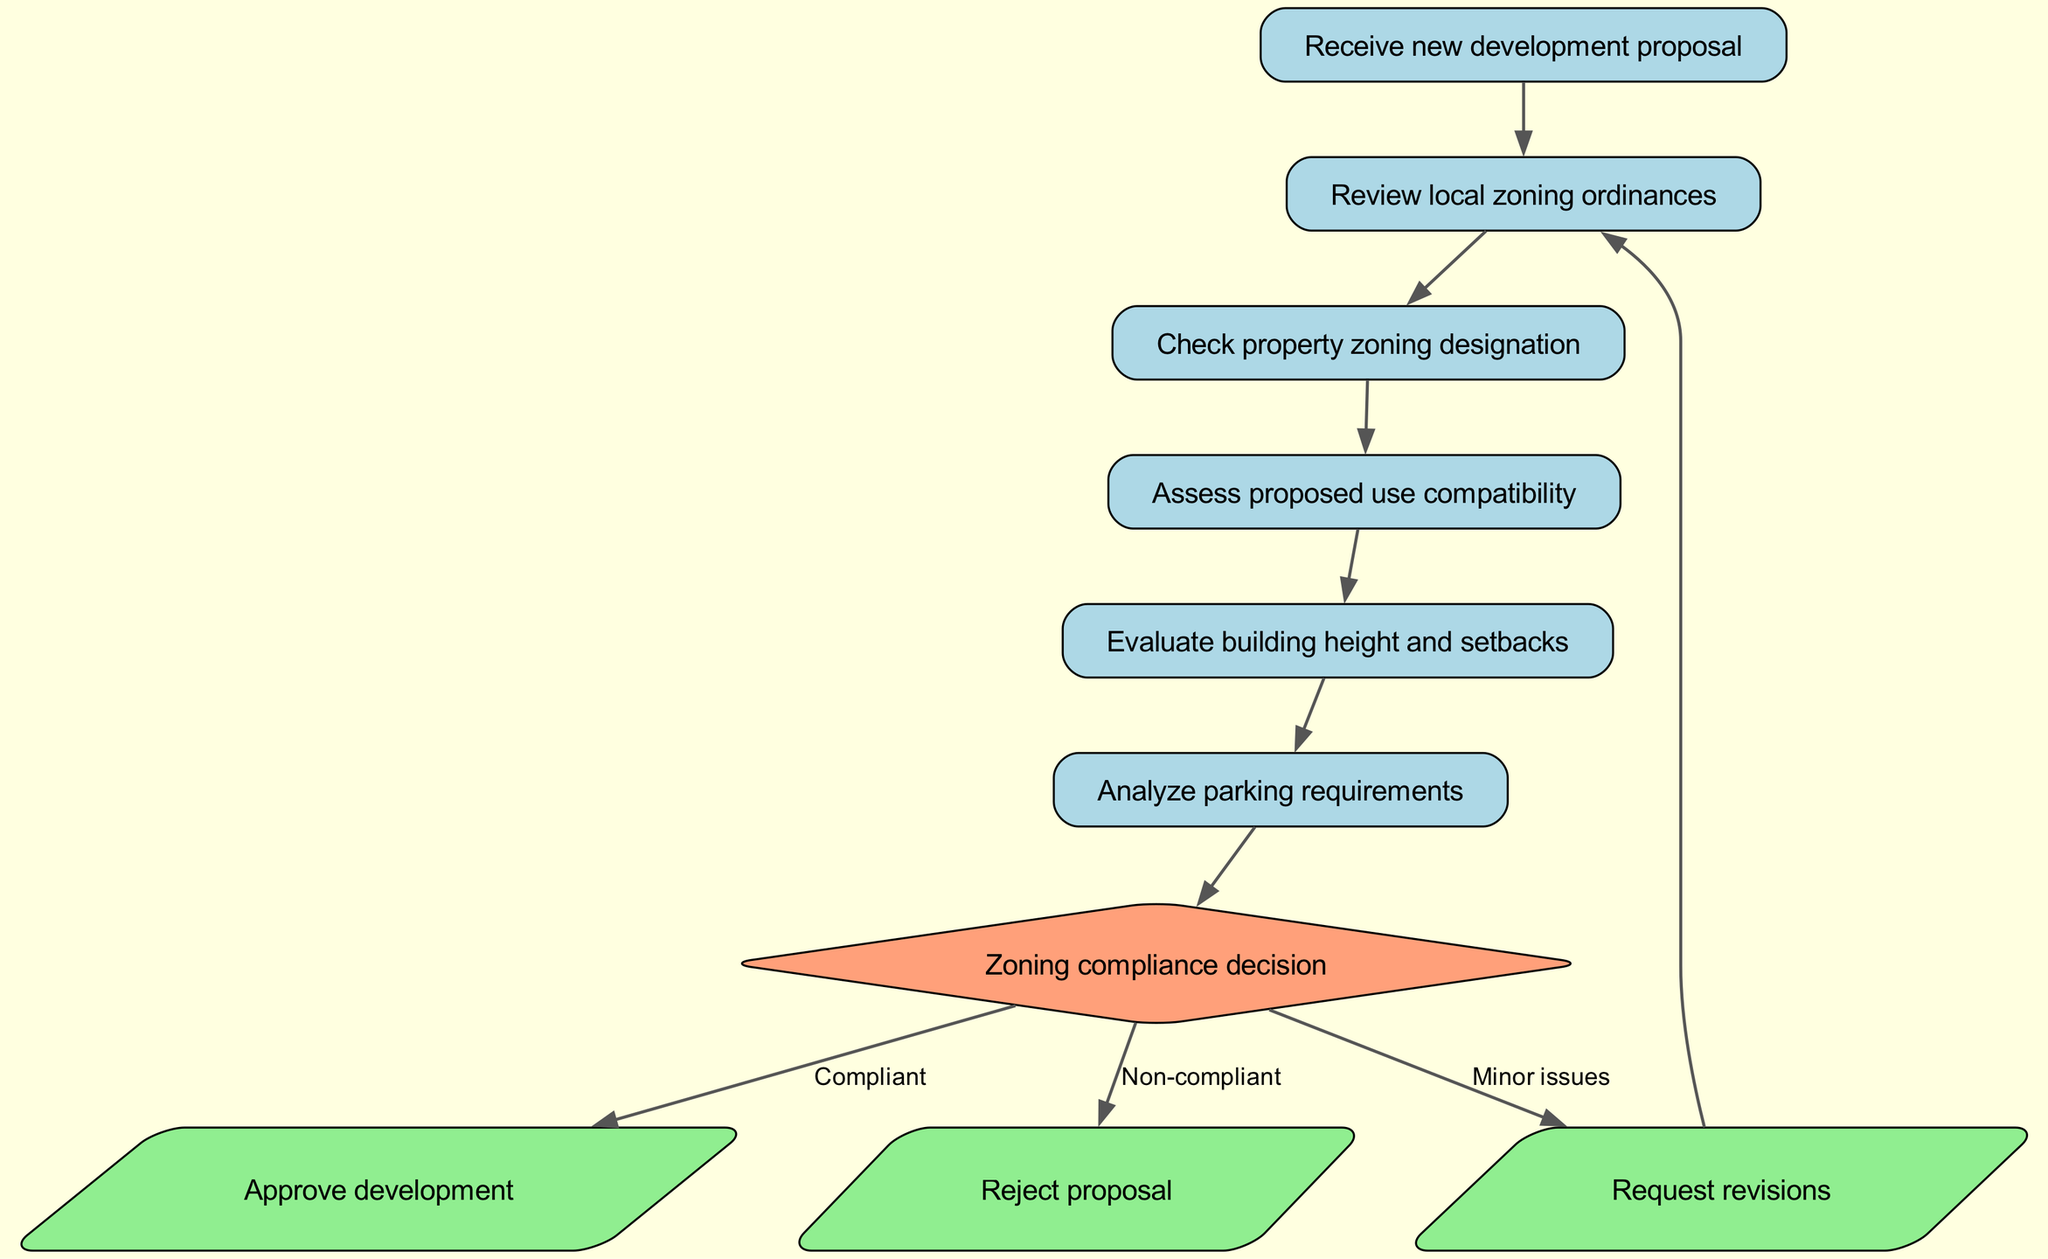What is the first step in the zoning compliance evaluation process? The first step in the process, indicated by the node labeled "Receive new development proposal," is where the evaluation begins. This node is at the top of the flow chart.
Answer: Receive new development proposal How many main decision points are there in the flow chart? The main decision point is represented by the node labeled "Zoning compliance decision." There are three outcomes from this decision: approve, reject, or request revisions. Thus, there is one main decision point in the flow chart.
Answer: One What does the node "Assess proposed use compatibility" lead to? From the node "Assess proposed use compatibility," the flow continues to the node "Evaluate building height and setbacks." This sequential connection indicates the next step in the evaluation process.
Answer: Evaluate building height and setbacks What happens if a proposal is non-compliant? If the proposal is determined to be non-compliant, it leads to the node labeled "Reject proposal," indicating that the development cannot proceed in its current form.
Answer: Reject proposal What action is taken if there are minor issues with a proposal? If minor issues are identified, the flow indicates that revisions are requested, leading to the node labeled "Request revisions." This shows that some adjustments are needed before re-evaluation.
Answer: Request revisions In what order do the zoning compliance evaluations occur? The evaluations occur in a specific order: First, review local zoning ordinances, then check property zoning designation, assess proposed use compatibility, evaluate building height and setbacks, and analyze parking requirements. This clear sequential flow outlines each step.
Answer: Review, check, assess, evaluate, analyze What shape is used to represent the zoning compliance decision node? The zoning compliance decision node is represented by a diamond shape, which is a common representation for decision points in flow charts. This visual distinction highlights its role in determining the outcome of the evaluation process.
Answer: Diamond Which node indicates the approval of a development? The node that indicates the approval of a development is labeled "Approve development." This outcome is reached if the proposal is compliant with all zoning requirements.
Answer: Approve development What is the function of the "Revise" node in the diagram? The "Revise" node serves as a pivotal point where the proposal is returned for modifications if minor issues are found. It leads back to the initial review phase, ensuring that compliance can eventually be achieved.
Answer: Request revisions 